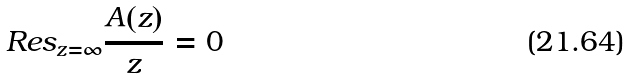Convert formula to latex. <formula><loc_0><loc_0><loc_500><loc_500>R e s _ { z = \infty } \frac { A ( z ) } { z } = 0</formula> 